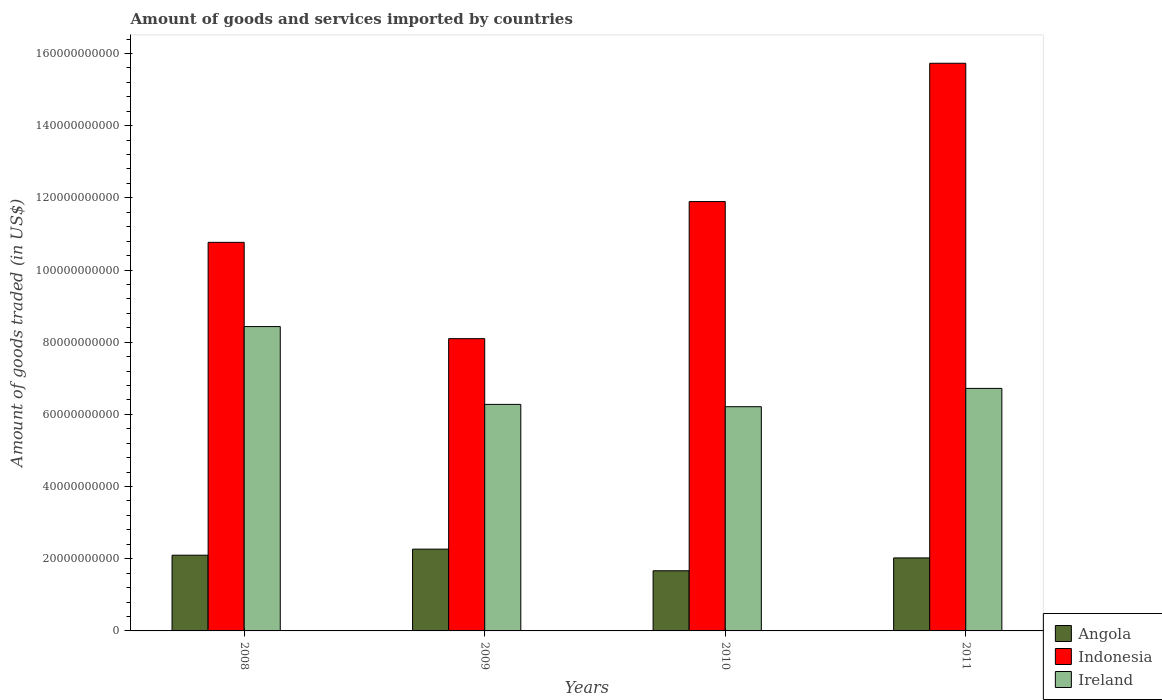How many groups of bars are there?
Offer a very short reply. 4. How many bars are there on the 1st tick from the left?
Offer a very short reply. 3. How many bars are there on the 2nd tick from the right?
Offer a very short reply. 3. In how many cases, is the number of bars for a given year not equal to the number of legend labels?
Keep it short and to the point. 0. What is the total amount of goods and services imported in Indonesia in 2009?
Keep it short and to the point. 8.10e+1. Across all years, what is the maximum total amount of goods and services imported in Angola?
Your answer should be compact. 2.27e+1. Across all years, what is the minimum total amount of goods and services imported in Indonesia?
Ensure brevity in your answer.  8.10e+1. In which year was the total amount of goods and services imported in Ireland minimum?
Ensure brevity in your answer.  2010. What is the total total amount of goods and services imported in Indonesia in the graph?
Offer a very short reply. 4.65e+11. What is the difference between the total amount of goods and services imported in Indonesia in 2010 and that in 2011?
Provide a succinct answer. -3.83e+1. What is the difference between the total amount of goods and services imported in Indonesia in 2008 and the total amount of goods and services imported in Ireland in 2010?
Make the answer very short. 4.55e+1. What is the average total amount of goods and services imported in Indonesia per year?
Your answer should be very brief. 1.16e+11. In the year 2008, what is the difference between the total amount of goods and services imported in Indonesia and total amount of goods and services imported in Angola?
Keep it short and to the point. 8.67e+1. What is the ratio of the total amount of goods and services imported in Angola in 2008 to that in 2011?
Provide a short and direct response. 1.04. Is the total amount of goods and services imported in Ireland in 2009 less than that in 2011?
Your answer should be compact. Yes. Is the difference between the total amount of goods and services imported in Indonesia in 2008 and 2009 greater than the difference between the total amount of goods and services imported in Angola in 2008 and 2009?
Offer a terse response. Yes. What is the difference between the highest and the second highest total amount of goods and services imported in Angola?
Offer a very short reply. 1.68e+09. What is the difference between the highest and the lowest total amount of goods and services imported in Ireland?
Give a very brief answer. 2.22e+1. Is the sum of the total amount of goods and services imported in Angola in 2010 and 2011 greater than the maximum total amount of goods and services imported in Indonesia across all years?
Make the answer very short. No. What does the 1st bar from the left in 2009 represents?
Offer a terse response. Angola. What does the 3rd bar from the right in 2011 represents?
Your response must be concise. Angola. Is it the case that in every year, the sum of the total amount of goods and services imported in Angola and total amount of goods and services imported in Indonesia is greater than the total amount of goods and services imported in Ireland?
Ensure brevity in your answer.  Yes. Are all the bars in the graph horizontal?
Your answer should be compact. No. How many years are there in the graph?
Give a very brief answer. 4. Are the values on the major ticks of Y-axis written in scientific E-notation?
Keep it short and to the point. No. Does the graph contain any zero values?
Make the answer very short. No. Where does the legend appear in the graph?
Ensure brevity in your answer.  Bottom right. How are the legend labels stacked?
Keep it short and to the point. Vertical. What is the title of the graph?
Your answer should be compact. Amount of goods and services imported by countries. Does "Thailand" appear as one of the legend labels in the graph?
Your answer should be compact. No. What is the label or title of the X-axis?
Provide a succinct answer. Years. What is the label or title of the Y-axis?
Give a very brief answer. Amount of goods traded (in US$). What is the Amount of goods traded (in US$) of Angola in 2008?
Your answer should be very brief. 2.10e+1. What is the Amount of goods traded (in US$) in Indonesia in 2008?
Your answer should be very brief. 1.08e+11. What is the Amount of goods traded (in US$) in Ireland in 2008?
Your response must be concise. 8.43e+1. What is the Amount of goods traded (in US$) in Angola in 2009?
Your answer should be compact. 2.27e+1. What is the Amount of goods traded (in US$) in Indonesia in 2009?
Provide a succinct answer. 8.10e+1. What is the Amount of goods traded (in US$) in Ireland in 2009?
Your response must be concise. 6.28e+1. What is the Amount of goods traded (in US$) of Angola in 2010?
Provide a succinct answer. 1.67e+1. What is the Amount of goods traded (in US$) of Indonesia in 2010?
Provide a short and direct response. 1.19e+11. What is the Amount of goods traded (in US$) in Ireland in 2010?
Provide a succinct answer. 6.21e+1. What is the Amount of goods traded (in US$) in Angola in 2011?
Your answer should be very brief. 2.02e+1. What is the Amount of goods traded (in US$) of Indonesia in 2011?
Provide a succinct answer. 1.57e+11. What is the Amount of goods traded (in US$) in Ireland in 2011?
Make the answer very short. 6.72e+1. Across all years, what is the maximum Amount of goods traded (in US$) in Angola?
Give a very brief answer. 2.27e+1. Across all years, what is the maximum Amount of goods traded (in US$) in Indonesia?
Offer a very short reply. 1.57e+11. Across all years, what is the maximum Amount of goods traded (in US$) in Ireland?
Give a very brief answer. 8.43e+1. Across all years, what is the minimum Amount of goods traded (in US$) in Angola?
Your answer should be very brief. 1.67e+1. Across all years, what is the minimum Amount of goods traded (in US$) in Indonesia?
Give a very brief answer. 8.10e+1. Across all years, what is the minimum Amount of goods traded (in US$) in Ireland?
Ensure brevity in your answer.  6.21e+1. What is the total Amount of goods traded (in US$) of Angola in the graph?
Provide a short and direct response. 8.05e+1. What is the total Amount of goods traded (in US$) in Indonesia in the graph?
Offer a very short reply. 4.65e+11. What is the total Amount of goods traded (in US$) of Ireland in the graph?
Your answer should be very brief. 2.76e+11. What is the difference between the Amount of goods traded (in US$) of Angola in 2008 and that in 2009?
Ensure brevity in your answer.  -1.68e+09. What is the difference between the Amount of goods traded (in US$) in Indonesia in 2008 and that in 2009?
Keep it short and to the point. 2.67e+1. What is the difference between the Amount of goods traded (in US$) of Ireland in 2008 and that in 2009?
Provide a short and direct response. 2.16e+1. What is the difference between the Amount of goods traded (in US$) of Angola in 2008 and that in 2010?
Offer a very short reply. 4.32e+09. What is the difference between the Amount of goods traded (in US$) in Indonesia in 2008 and that in 2010?
Make the answer very short. -1.13e+1. What is the difference between the Amount of goods traded (in US$) in Ireland in 2008 and that in 2010?
Keep it short and to the point. 2.22e+1. What is the difference between the Amount of goods traded (in US$) in Angola in 2008 and that in 2011?
Your answer should be very brief. 7.54e+08. What is the difference between the Amount of goods traded (in US$) of Indonesia in 2008 and that in 2011?
Make the answer very short. -4.96e+1. What is the difference between the Amount of goods traded (in US$) in Ireland in 2008 and that in 2011?
Provide a short and direct response. 1.71e+1. What is the difference between the Amount of goods traded (in US$) in Angola in 2009 and that in 2010?
Make the answer very short. 5.99e+09. What is the difference between the Amount of goods traded (in US$) in Indonesia in 2009 and that in 2010?
Offer a terse response. -3.80e+1. What is the difference between the Amount of goods traded (in US$) of Ireland in 2009 and that in 2010?
Keep it short and to the point. 6.44e+08. What is the difference between the Amount of goods traded (in US$) in Angola in 2009 and that in 2011?
Your answer should be compact. 2.43e+09. What is the difference between the Amount of goods traded (in US$) of Indonesia in 2009 and that in 2011?
Keep it short and to the point. -7.63e+1. What is the difference between the Amount of goods traded (in US$) in Ireland in 2009 and that in 2011?
Provide a short and direct response. -4.43e+09. What is the difference between the Amount of goods traded (in US$) of Angola in 2010 and that in 2011?
Keep it short and to the point. -3.56e+09. What is the difference between the Amount of goods traded (in US$) in Indonesia in 2010 and that in 2011?
Make the answer very short. -3.83e+1. What is the difference between the Amount of goods traded (in US$) in Ireland in 2010 and that in 2011?
Your answer should be very brief. -5.07e+09. What is the difference between the Amount of goods traded (in US$) in Angola in 2008 and the Amount of goods traded (in US$) in Indonesia in 2009?
Make the answer very short. -6.00e+1. What is the difference between the Amount of goods traded (in US$) of Angola in 2008 and the Amount of goods traded (in US$) of Ireland in 2009?
Keep it short and to the point. -4.18e+1. What is the difference between the Amount of goods traded (in US$) in Indonesia in 2008 and the Amount of goods traded (in US$) in Ireland in 2009?
Provide a succinct answer. 4.49e+1. What is the difference between the Amount of goods traded (in US$) in Angola in 2008 and the Amount of goods traded (in US$) in Indonesia in 2010?
Make the answer very short. -9.80e+1. What is the difference between the Amount of goods traded (in US$) of Angola in 2008 and the Amount of goods traded (in US$) of Ireland in 2010?
Keep it short and to the point. -4.11e+1. What is the difference between the Amount of goods traded (in US$) in Indonesia in 2008 and the Amount of goods traded (in US$) in Ireland in 2010?
Give a very brief answer. 4.55e+1. What is the difference between the Amount of goods traded (in US$) of Angola in 2008 and the Amount of goods traded (in US$) of Indonesia in 2011?
Give a very brief answer. -1.36e+11. What is the difference between the Amount of goods traded (in US$) of Angola in 2008 and the Amount of goods traded (in US$) of Ireland in 2011?
Ensure brevity in your answer.  -4.62e+1. What is the difference between the Amount of goods traded (in US$) in Indonesia in 2008 and the Amount of goods traded (in US$) in Ireland in 2011?
Offer a terse response. 4.05e+1. What is the difference between the Amount of goods traded (in US$) in Angola in 2009 and the Amount of goods traded (in US$) in Indonesia in 2010?
Make the answer very short. -9.63e+1. What is the difference between the Amount of goods traded (in US$) of Angola in 2009 and the Amount of goods traded (in US$) of Ireland in 2010?
Offer a terse response. -3.95e+1. What is the difference between the Amount of goods traded (in US$) of Indonesia in 2009 and the Amount of goods traded (in US$) of Ireland in 2010?
Your answer should be very brief. 1.89e+1. What is the difference between the Amount of goods traded (in US$) of Angola in 2009 and the Amount of goods traded (in US$) of Indonesia in 2011?
Ensure brevity in your answer.  -1.35e+11. What is the difference between the Amount of goods traded (in US$) in Angola in 2009 and the Amount of goods traded (in US$) in Ireland in 2011?
Offer a terse response. -4.45e+1. What is the difference between the Amount of goods traded (in US$) of Indonesia in 2009 and the Amount of goods traded (in US$) of Ireland in 2011?
Your response must be concise. 1.38e+1. What is the difference between the Amount of goods traded (in US$) of Angola in 2010 and the Amount of goods traded (in US$) of Indonesia in 2011?
Your answer should be compact. -1.41e+11. What is the difference between the Amount of goods traded (in US$) in Angola in 2010 and the Amount of goods traded (in US$) in Ireland in 2011?
Keep it short and to the point. -5.05e+1. What is the difference between the Amount of goods traded (in US$) of Indonesia in 2010 and the Amount of goods traded (in US$) of Ireland in 2011?
Provide a succinct answer. 5.18e+1. What is the average Amount of goods traded (in US$) of Angola per year?
Your answer should be compact. 2.01e+1. What is the average Amount of goods traded (in US$) in Indonesia per year?
Provide a succinct answer. 1.16e+11. What is the average Amount of goods traded (in US$) in Ireland per year?
Your response must be concise. 6.91e+1. In the year 2008, what is the difference between the Amount of goods traded (in US$) of Angola and Amount of goods traded (in US$) of Indonesia?
Give a very brief answer. -8.67e+1. In the year 2008, what is the difference between the Amount of goods traded (in US$) of Angola and Amount of goods traded (in US$) of Ireland?
Your response must be concise. -6.33e+1. In the year 2008, what is the difference between the Amount of goods traded (in US$) in Indonesia and Amount of goods traded (in US$) in Ireland?
Your response must be concise. 2.33e+1. In the year 2009, what is the difference between the Amount of goods traded (in US$) in Angola and Amount of goods traded (in US$) in Indonesia?
Keep it short and to the point. -5.83e+1. In the year 2009, what is the difference between the Amount of goods traded (in US$) of Angola and Amount of goods traded (in US$) of Ireland?
Your answer should be compact. -4.01e+1. In the year 2009, what is the difference between the Amount of goods traded (in US$) of Indonesia and Amount of goods traded (in US$) of Ireland?
Give a very brief answer. 1.82e+1. In the year 2010, what is the difference between the Amount of goods traded (in US$) of Angola and Amount of goods traded (in US$) of Indonesia?
Your answer should be very brief. -1.02e+11. In the year 2010, what is the difference between the Amount of goods traded (in US$) in Angola and Amount of goods traded (in US$) in Ireland?
Your answer should be compact. -4.55e+1. In the year 2010, what is the difference between the Amount of goods traded (in US$) in Indonesia and Amount of goods traded (in US$) in Ireland?
Offer a very short reply. 5.68e+1. In the year 2011, what is the difference between the Amount of goods traded (in US$) of Angola and Amount of goods traded (in US$) of Indonesia?
Make the answer very short. -1.37e+11. In the year 2011, what is the difference between the Amount of goods traded (in US$) of Angola and Amount of goods traded (in US$) of Ireland?
Your answer should be compact. -4.70e+1. In the year 2011, what is the difference between the Amount of goods traded (in US$) in Indonesia and Amount of goods traded (in US$) in Ireland?
Provide a short and direct response. 9.01e+1. What is the ratio of the Amount of goods traded (in US$) in Angola in 2008 to that in 2009?
Ensure brevity in your answer.  0.93. What is the ratio of the Amount of goods traded (in US$) of Indonesia in 2008 to that in 2009?
Offer a very short reply. 1.33. What is the ratio of the Amount of goods traded (in US$) in Ireland in 2008 to that in 2009?
Keep it short and to the point. 1.34. What is the ratio of the Amount of goods traded (in US$) in Angola in 2008 to that in 2010?
Provide a succinct answer. 1.26. What is the ratio of the Amount of goods traded (in US$) of Indonesia in 2008 to that in 2010?
Make the answer very short. 0.91. What is the ratio of the Amount of goods traded (in US$) of Ireland in 2008 to that in 2010?
Offer a terse response. 1.36. What is the ratio of the Amount of goods traded (in US$) in Angola in 2008 to that in 2011?
Your answer should be compact. 1.04. What is the ratio of the Amount of goods traded (in US$) of Indonesia in 2008 to that in 2011?
Keep it short and to the point. 0.68. What is the ratio of the Amount of goods traded (in US$) of Ireland in 2008 to that in 2011?
Make the answer very short. 1.25. What is the ratio of the Amount of goods traded (in US$) of Angola in 2009 to that in 2010?
Keep it short and to the point. 1.36. What is the ratio of the Amount of goods traded (in US$) of Indonesia in 2009 to that in 2010?
Give a very brief answer. 0.68. What is the ratio of the Amount of goods traded (in US$) of Ireland in 2009 to that in 2010?
Offer a very short reply. 1.01. What is the ratio of the Amount of goods traded (in US$) in Angola in 2009 to that in 2011?
Ensure brevity in your answer.  1.12. What is the ratio of the Amount of goods traded (in US$) of Indonesia in 2009 to that in 2011?
Offer a terse response. 0.51. What is the ratio of the Amount of goods traded (in US$) in Ireland in 2009 to that in 2011?
Your answer should be compact. 0.93. What is the ratio of the Amount of goods traded (in US$) of Angola in 2010 to that in 2011?
Offer a very short reply. 0.82. What is the ratio of the Amount of goods traded (in US$) of Indonesia in 2010 to that in 2011?
Your response must be concise. 0.76. What is the ratio of the Amount of goods traded (in US$) of Ireland in 2010 to that in 2011?
Offer a terse response. 0.92. What is the difference between the highest and the second highest Amount of goods traded (in US$) in Angola?
Provide a succinct answer. 1.68e+09. What is the difference between the highest and the second highest Amount of goods traded (in US$) of Indonesia?
Your answer should be compact. 3.83e+1. What is the difference between the highest and the second highest Amount of goods traded (in US$) in Ireland?
Offer a terse response. 1.71e+1. What is the difference between the highest and the lowest Amount of goods traded (in US$) of Angola?
Your answer should be compact. 5.99e+09. What is the difference between the highest and the lowest Amount of goods traded (in US$) of Indonesia?
Offer a terse response. 7.63e+1. What is the difference between the highest and the lowest Amount of goods traded (in US$) of Ireland?
Your response must be concise. 2.22e+1. 